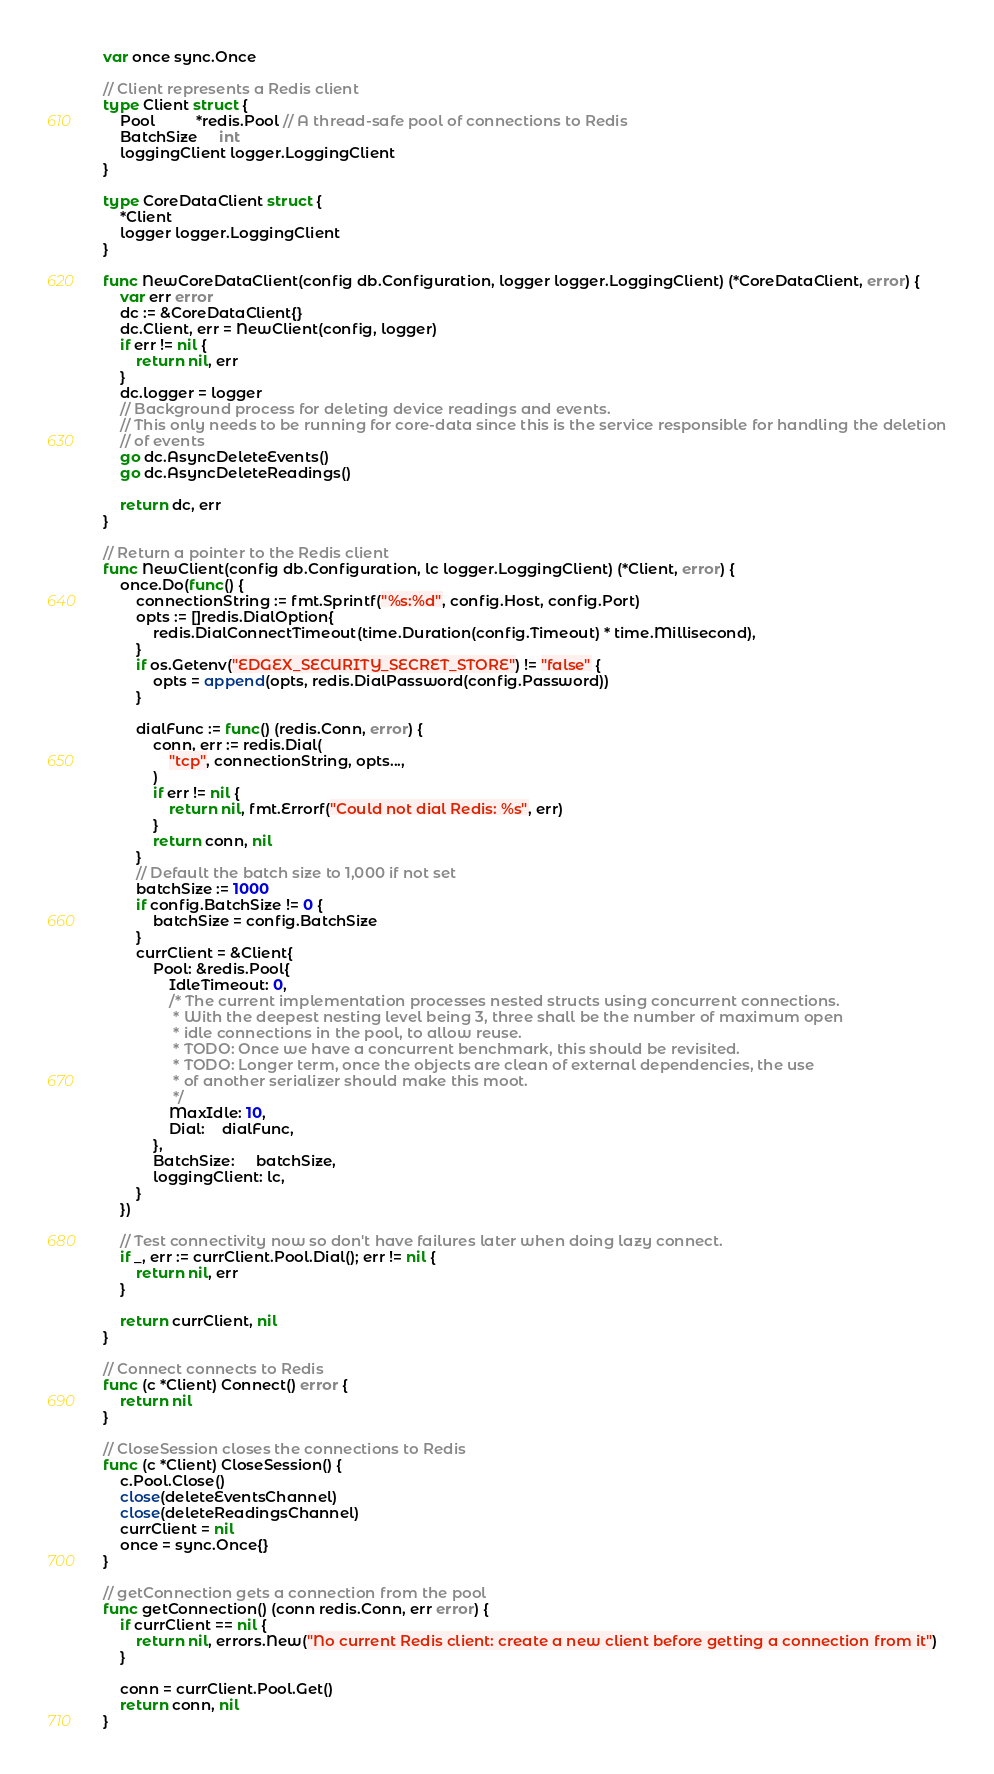Convert code to text. <code><loc_0><loc_0><loc_500><loc_500><_Go_>var once sync.Once

// Client represents a Redis client
type Client struct {
	Pool          *redis.Pool // A thread-safe pool of connections to Redis
	BatchSize     int
	loggingClient logger.LoggingClient
}

type CoreDataClient struct {
	*Client
	logger logger.LoggingClient
}

func NewCoreDataClient(config db.Configuration, logger logger.LoggingClient) (*CoreDataClient, error) {
	var err error
	dc := &CoreDataClient{}
	dc.Client, err = NewClient(config, logger)
	if err != nil {
		return nil, err
	}
	dc.logger = logger
	// Background process for deleting device readings and events.
	// This only needs to be running for core-data since this is the service responsible for handling the deletion
	// of events
	go dc.AsyncDeleteEvents()
	go dc.AsyncDeleteReadings()

	return dc, err
}

// Return a pointer to the Redis client
func NewClient(config db.Configuration, lc logger.LoggingClient) (*Client, error) {
	once.Do(func() {
		connectionString := fmt.Sprintf("%s:%d", config.Host, config.Port)
		opts := []redis.DialOption{
			redis.DialConnectTimeout(time.Duration(config.Timeout) * time.Millisecond),
		}
		if os.Getenv("EDGEX_SECURITY_SECRET_STORE") != "false" {
			opts = append(opts, redis.DialPassword(config.Password))
		}

		dialFunc := func() (redis.Conn, error) {
			conn, err := redis.Dial(
				"tcp", connectionString, opts...,
			)
			if err != nil {
				return nil, fmt.Errorf("Could not dial Redis: %s", err)
			}
			return conn, nil
		}
		// Default the batch size to 1,000 if not set
		batchSize := 1000
		if config.BatchSize != 0 {
			batchSize = config.BatchSize
		}
		currClient = &Client{
			Pool: &redis.Pool{
				IdleTimeout: 0,
				/* The current implementation processes nested structs using concurrent connections.
				 * With the deepest nesting level being 3, three shall be the number of maximum open
				 * idle connections in the pool, to allow reuse.
				 * TODO: Once we have a concurrent benchmark, this should be revisited.
				 * TODO: Longer term, once the objects are clean of external dependencies, the use
				 * of another serializer should make this moot.
				 */
				MaxIdle: 10,
				Dial:    dialFunc,
			},
			BatchSize:     batchSize,
			loggingClient: lc,
		}
	})

	// Test connectivity now so don't have failures later when doing lazy connect.
	if _, err := currClient.Pool.Dial(); err != nil {
		return nil, err
	}

	return currClient, nil
}

// Connect connects to Redis
func (c *Client) Connect() error {
	return nil
}

// CloseSession closes the connections to Redis
func (c *Client) CloseSession() {
	c.Pool.Close()
	close(deleteEventsChannel)
	close(deleteReadingsChannel)
	currClient = nil
	once = sync.Once{}
}

// getConnection gets a connection from the pool
func getConnection() (conn redis.Conn, err error) {
	if currClient == nil {
		return nil, errors.New("No current Redis client: create a new client before getting a connection from it")
	}

	conn = currClient.Pool.Get()
	return conn, nil
}
</code> 